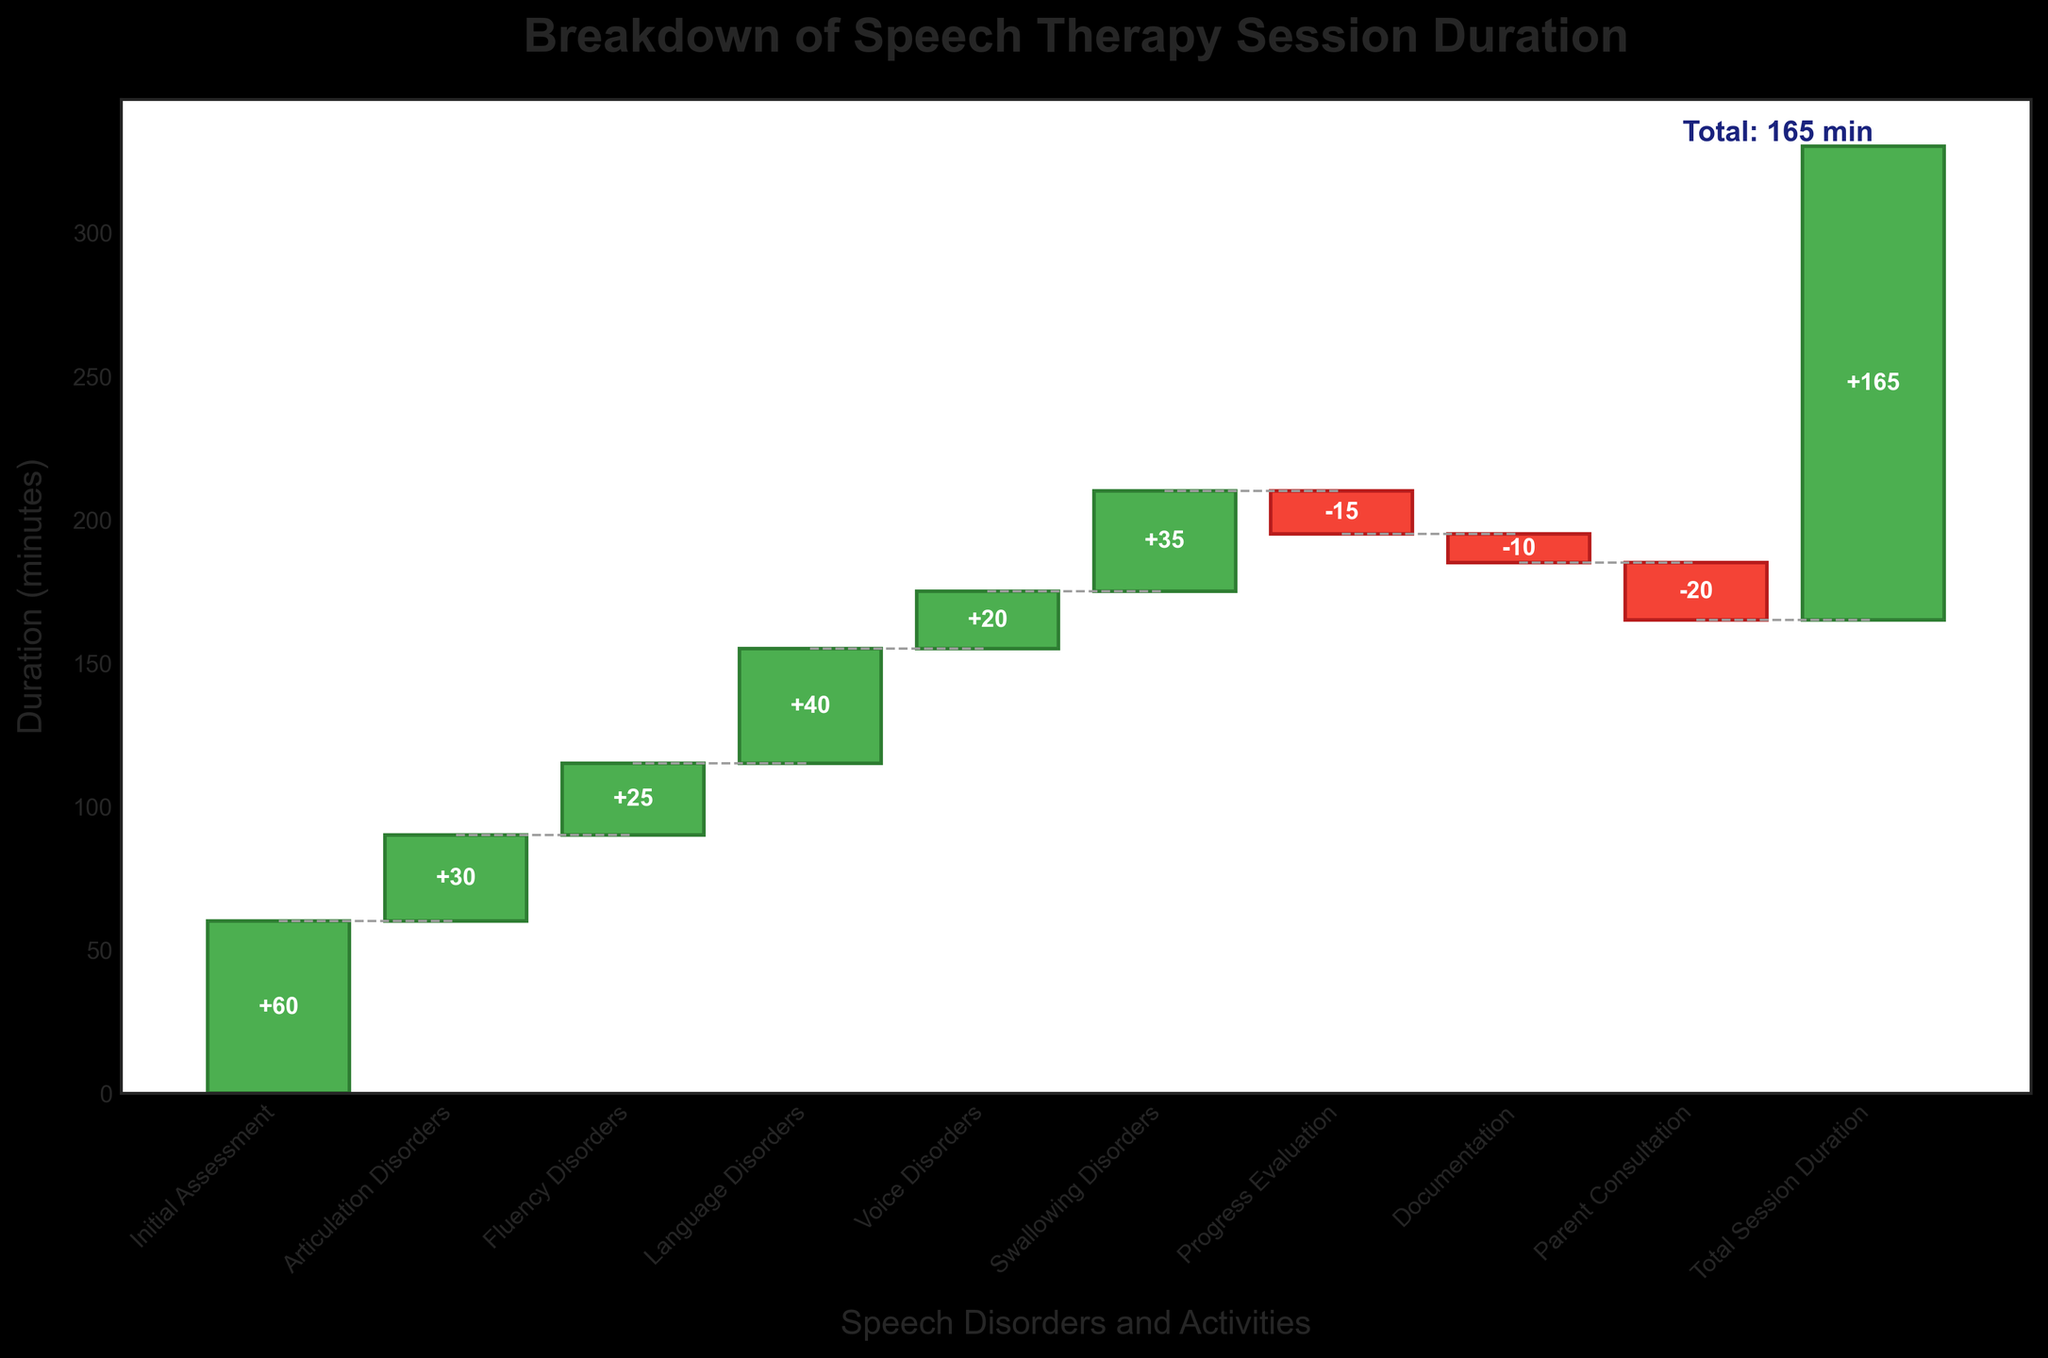What is the total duration of the speech therapy session according to the figure? The title of the figure includes "Total Session Duration" and the data point at the end of the waterfall chart also indicates the total duration. Reading the label on the last bar shows a duration of 165 minutes.
Answer: 165 minutes Which disorder has the longest dedicated session duration? By comparing the height of all bars, the initial assessment bar is the clearly longest. The label indicates it has a duration of 60 minutes.
Answer: Initial Assessment How does the duration of the fluency disorder session compare to the voice disorder session? The label on the fluency disorder bar indicates 25 minutes, while the label on the voice disorder bar shows 20 minutes. A simple subtraction shows that the fluency disorder session is longer.
Answer: Fluency Disorder What is the cumulative duration after the articulation disorders session? The articulation disorders session is the second bar with a duration of 30 minutes. Adding this to the initial assessment (60 minutes) gives a cumulative duration of 90 minutes.
Answer: 90 minutes What is the difference in duration between the language disorders and swallowing disorders sessions? The duration of the language disorders session is 40 minutes and the duration of the swallowing disorders session is 35 minutes. Subtracting these values gives 5 minutes.
Answer: 5 minutes What color represents reductions in session duration, and which activities fall under this category? The bars representing reductions are colored red. The labels on these bars indicate reductions for Progress Evaluation (-15 minutes), Documentation (-10 minutes), and Parent Consultation (-20 minutes).
Answer: Red, Progress Evaluation, Documentation, Parent Consultation What is the cumulative duration at the end of the parent consultation? To find this, subtract the negative contributions from the initial positive durations. After articulation disorders, fluency disorders, language disorders, and voice disorders, the duration is 155 minutes (60 + 30 + 25 + 40). Adding swallowing disorders, we get 190 minutes (155 + 35). Subtracting progress evaluation results in 175 minutes (190 - 15), then documentation gives 165 minutes (175 - 10). Finally, parent consultation results in 145 minutes (165 - 20).
Answer: 145 minutes How many types of disorders and activities are represented in the waterfall chart? Counting the number of bars in the figure, we include all positive and negative durations as well as the total duration. This gives a total of 10.
Answer: 10 What is the final cumulative duration before considering any documentation time? Before documentation, we have the cumulative duration after swallowing disorders and progress evaluation. After swallowing disorders (190 minutes), subtracting progress evaluation (15 minutes) gives 175 minutes. So before any documentation time is considered, the cumulative duration stands at 175 minutes.
Answer: 175 minutes 